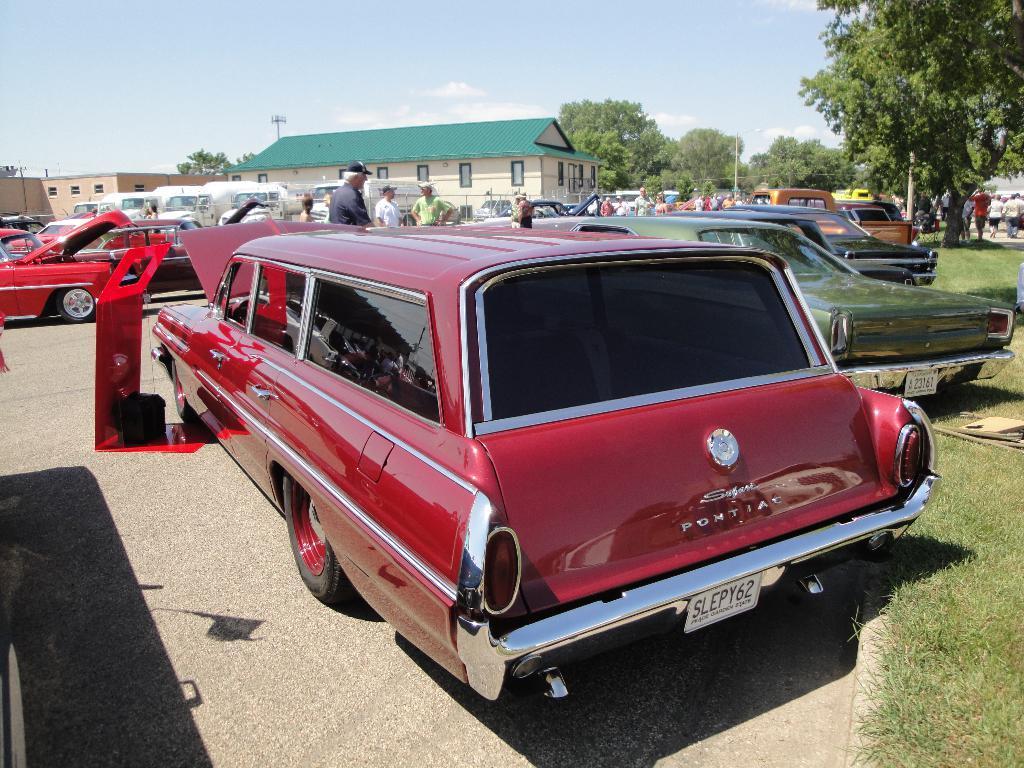Please provide a concise description of this image. In the picture I can see vehicles and people standing on the ground. In the background I can see buildings, trees, the grass, poles, the sky and some other objects. 